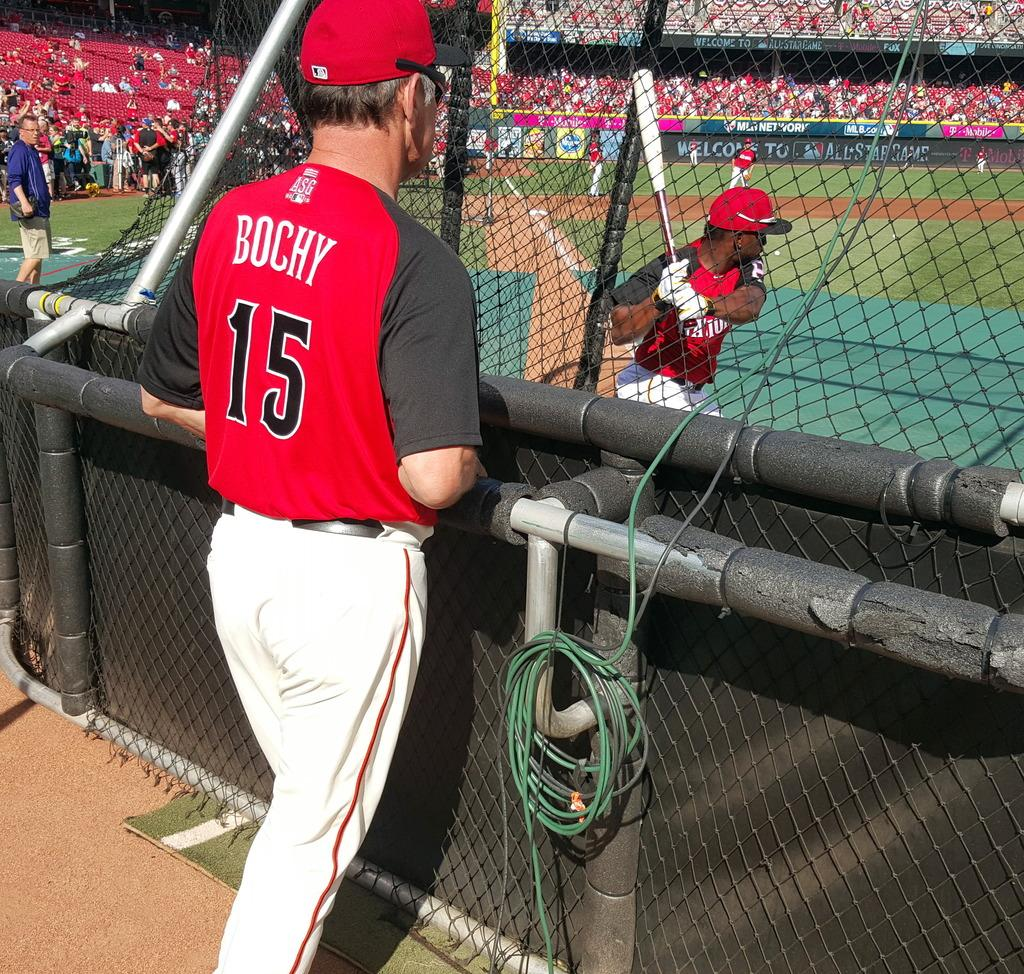<image>
Render a clear and concise summary of the photo. a player named BOCHY with the number 15 standing outside a baseball field 